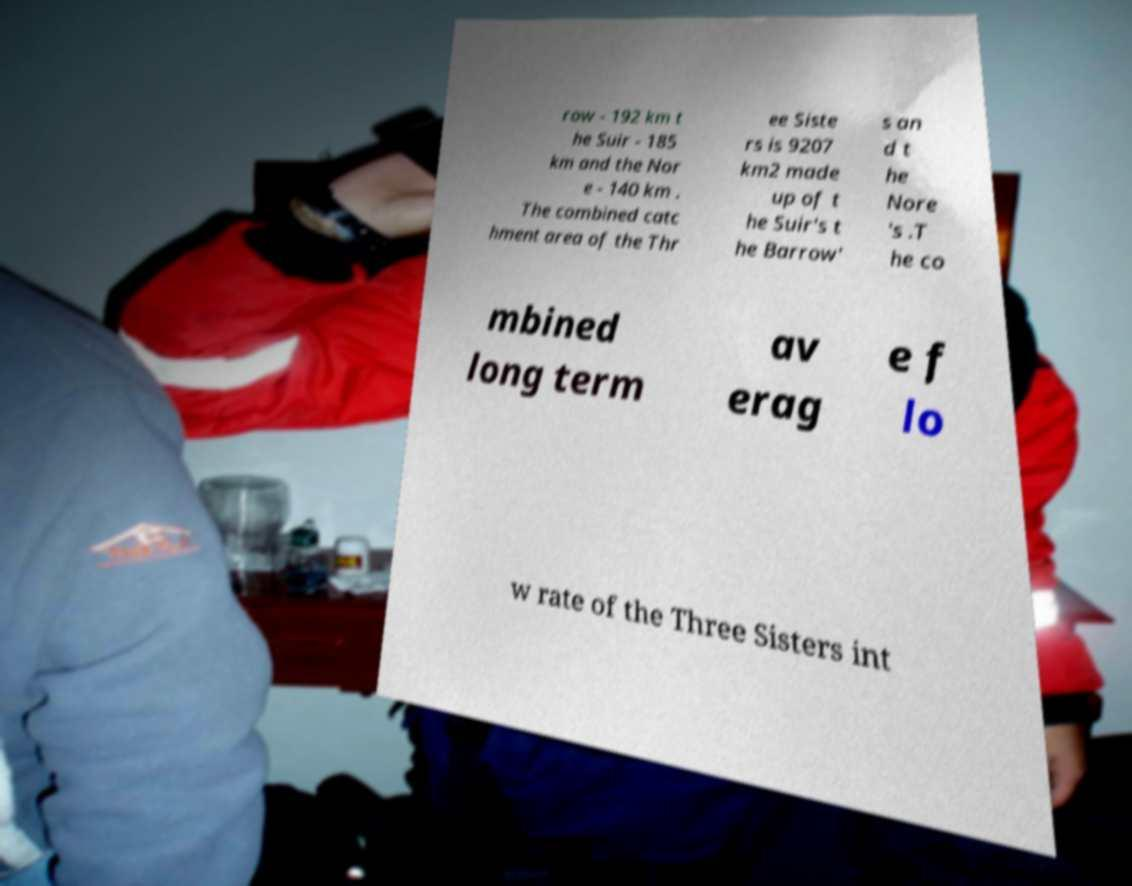Can you read and provide the text displayed in the image?This photo seems to have some interesting text. Can you extract and type it out for me? row - 192 km t he Suir - 185 km and the Nor e - 140 km . The combined catc hment area of the Thr ee Siste rs is 9207 km2 made up of t he Suir's t he Barrow' s an d t he Nore 's .T he co mbined long term av erag e f lo w rate of the Three Sisters int 